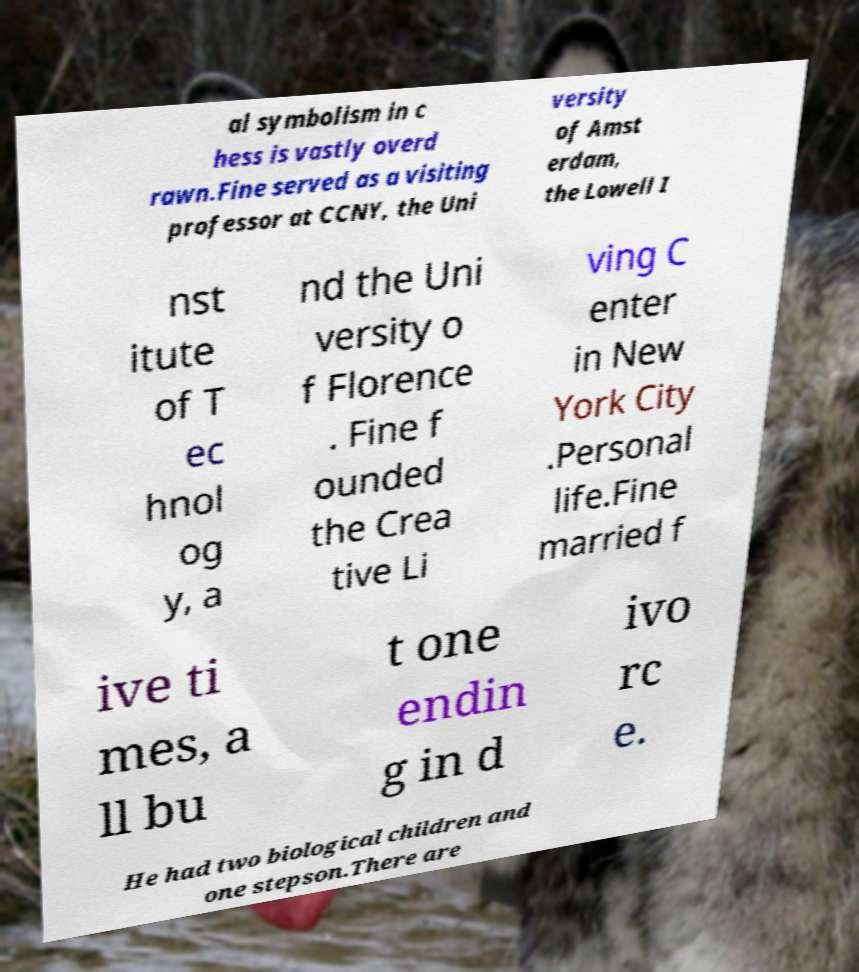Can you accurately transcribe the text from the provided image for me? al symbolism in c hess is vastly overd rawn.Fine served as a visiting professor at CCNY, the Uni versity of Amst erdam, the Lowell I nst itute of T ec hnol og y, a nd the Uni versity o f Florence . Fine f ounded the Crea tive Li ving C enter in New York City .Personal life.Fine married f ive ti mes, a ll bu t one endin g in d ivo rc e. He had two biological children and one stepson.There are 